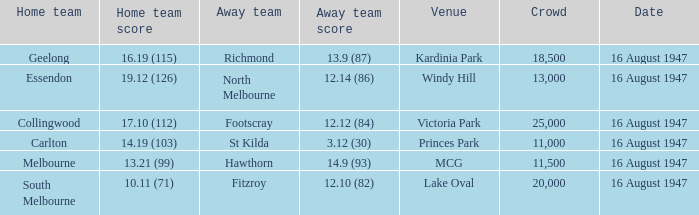For which home team has the audience size exceeded 20,000? Collingwood. 